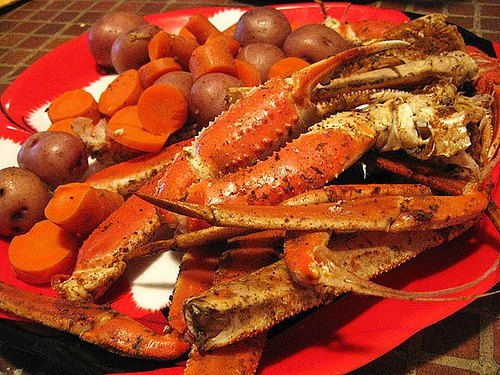Describe the objects in this image and their specific colors. I can see carrot in orange, red, brown, and maroon tones, carrot in orange, red, and brown tones, carrot in orange, red, brown, and maroon tones, carrot in orange, red, and brown tones, and carrot in orange, red, and brown tones in this image. 